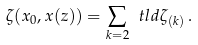<formula> <loc_0><loc_0><loc_500><loc_500>\zeta ( x _ { 0 } , x ( z ) ) = \sum _ { k = 2 } \ t l d { \zeta } _ { ( k ) } \, .</formula> 